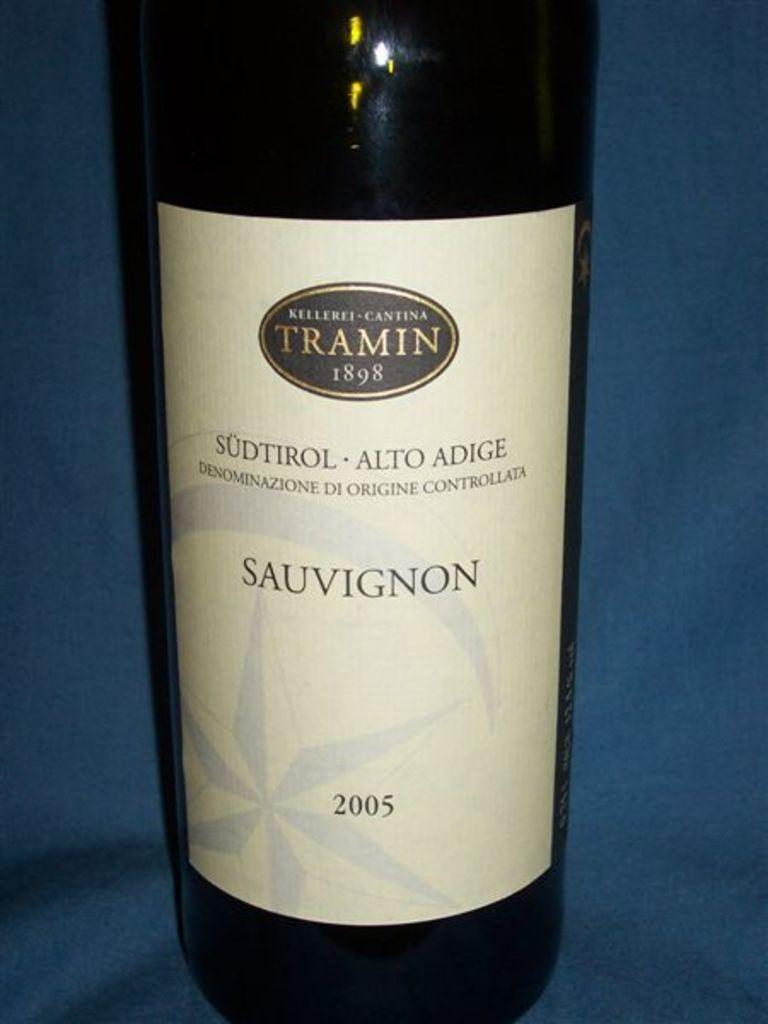<image>
Write a terse but informative summary of the picture. A bottle of Tramin Sauvignon wine from 2007. 